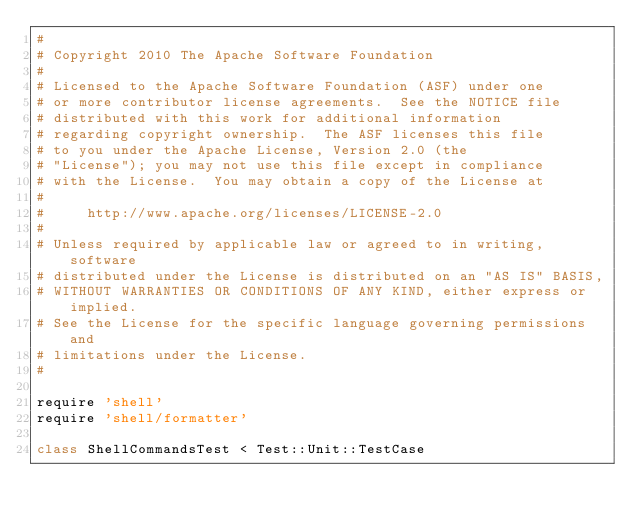<code> <loc_0><loc_0><loc_500><loc_500><_Ruby_>#
# Copyright 2010 The Apache Software Foundation
#
# Licensed to the Apache Software Foundation (ASF) under one
# or more contributor license agreements.  See the NOTICE file
# distributed with this work for additional information
# regarding copyright ownership.  The ASF licenses this file
# to you under the Apache License, Version 2.0 (the
# "License"); you may not use this file except in compliance
# with the License.  You may obtain a copy of the License at
#
#     http://www.apache.org/licenses/LICENSE-2.0
#
# Unless required by applicable law or agreed to in writing, software
# distributed under the License is distributed on an "AS IS" BASIS,
# WITHOUT WARRANTIES OR CONDITIONS OF ANY KIND, either express or implied.
# See the License for the specific language governing permissions and
# limitations under the License.
#

require 'shell'
require 'shell/formatter'

class ShellCommandsTest < Test::Unit::TestCase</code> 